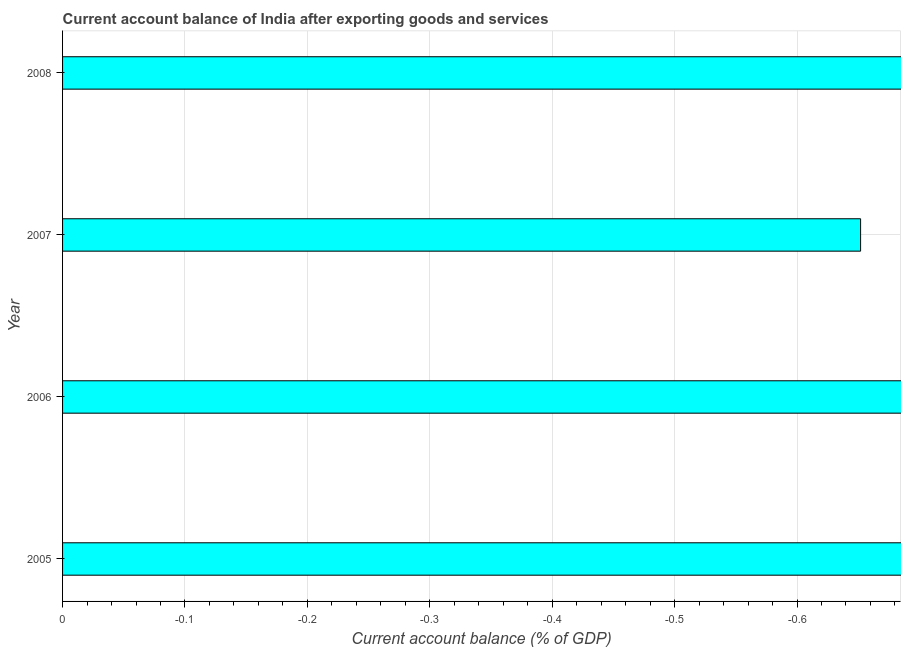Does the graph contain any zero values?
Provide a succinct answer. Yes. What is the title of the graph?
Make the answer very short. Current account balance of India after exporting goods and services. What is the label or title of the X-axis?
Your answer should be very brief. Current account balance (% of GDP). What is the label or title of the Y-axis?
Offer a very short reply. Year. Across all years, what is the minimum current account balance?
Offer a terse response. 0. What is the average current account balance per year?
Your response must be concise. 0. What is the median current account balance?
Keep it short and to the point. 0. In how many years, is the current account balance greater than -0.16 %?
Your answer should be very brief. 0. How many bars are there?
Make the answer very short. 0. Are all the bars in the graph horizontal?
Make the answer very short. Yes. What is the difference between two consecutive major ticks on the X-axis?
Offer a very short reply. 0.1. What is the Current account balance (% of GDP) of 2005?
Offer a terse response. 0. 